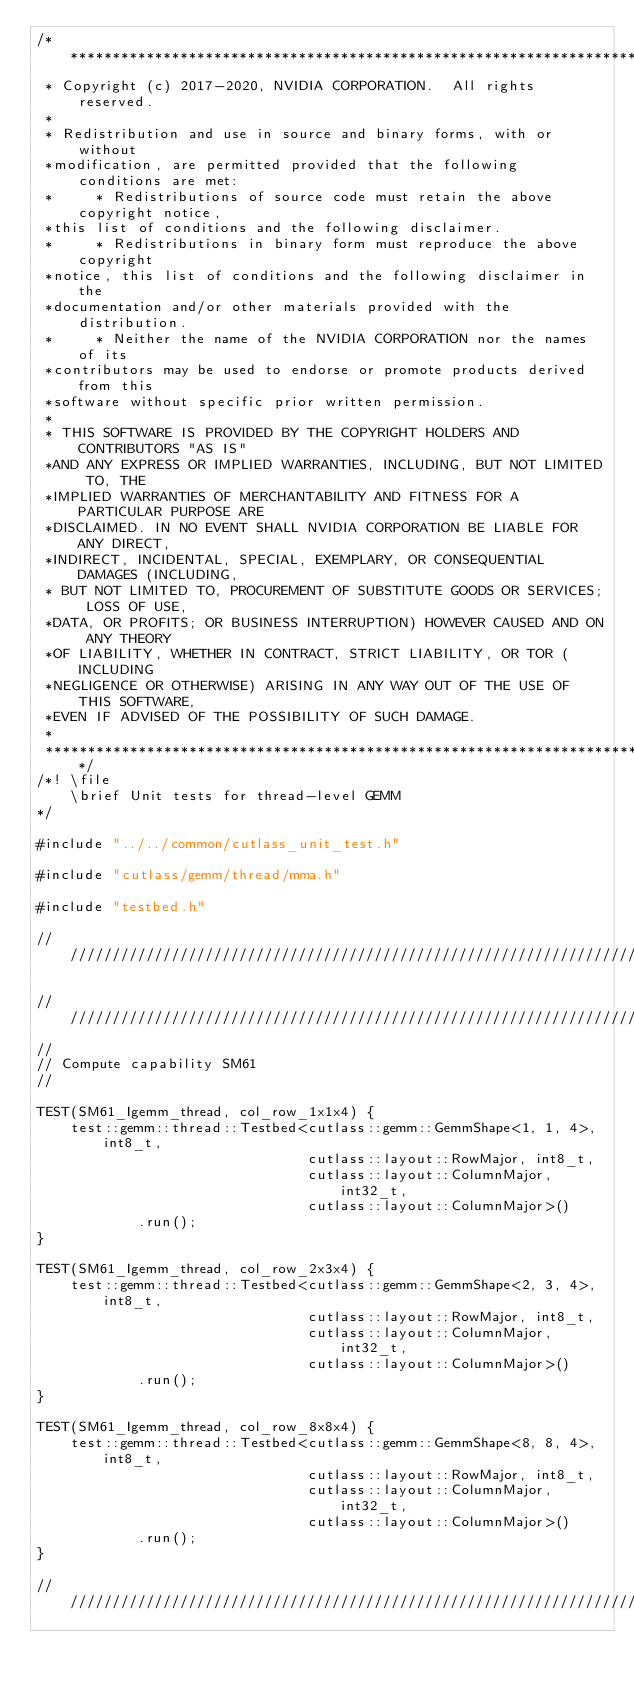<code> <loc_0><loc_0><loc_500><loc_500><_Cuda_>/***************************************************************************************************
 * Copyright (c) 2017-2020, NVIDIA CORPORATION.  All rights reserved.
 *
 * Redistribution and use in source and binary forms, with or without
 *modification, are permitted provided that the following conditions are met:
 *     * Redistributions of source code must retain the above copyright notice,
 *this list of conditions and the following disclaimer.
 *     * Redistributions in binary form must reproduce the above copyright
 *notice, this list of conditions and the following disclaimer in the
 *documentation and/or other materials provided with the distribution.
 *     * Neither the name of the NVIDIA CORPORATION nor the names of its
 *contributors may be used to endorse or promote products derived from this
 *software without specific prior written permission.
 *
 * THIS SOFTWARE IS PROVIDED BY THE COPYRIGHT HOLDERS AND CONTRIBUTORS "AS IS"
 *AND ANY EXPRESS OR IMPLIED WARRANTIES, INCLUDING, BUT NOT LIMITED TO, THE
 *IMPLIED WARRANTIES OF MERCHANTABILITY AND FITNESS FOR A PARTICULAR PURPOSE ARE
 *DISCLAIMED. IN NO EVENT SHALL NVIDIA CORPORATION BE LIABLE FOR ANY DIRECT,
 *INDIRECT, INCIDENTAL, SPECIAL, EXEMPLARY, OR CONSEQUENTIAL DAMAGES (INCLUDING,
 * BUT NOT LIMITED TO, PROCUREMENT OF SUBSTITUTE GOODS OR SERVICES; LOSS OF USE,
 *DATA, OR PROFITS; OR BUSINESS INTERRUPTION) HOWEVER CAUSED AND ON ANY THEORY
 *OF LIABILITY, WHETHER IN CONTRACT, STRICT LIABILITY, OR TOR (INCLUDING
 *NEGLIGENCE OR OTHERWISE) ARISING IN ANY WAY OUT OF THE USE OF THIS SOFTWARE,
 *EVEN IF ADVISED OF THE POSSIBILITY OF SUCH DAMAGE.
 *
 **************************************************************************************************/
/*! \file
    \brief Unit tests for thread-level GEMM
*/

#include "../../common/cutlass_unit_test.h"

#include "cutlass/gemm/thread/mma.h"

#include "testbed.h"

/////////////////////////////////////////////////////////////////////////////////////////////////

/////////////////////////////////////////////////////////////////////////////////////////////////
//
// Compute capability SM61
//

TEST(SM61_Igemm_thread, col_row_1x1x4) {
    test::gemm::thread::Testbed<cutlass::gemm::GemmShape<1, 1, 4>, int8_t,
                                cutlass::layout::RowMajor, int8_t,
                                cutlass::layout::ColumnMajor, int32_t,
                                cutlass::layout::ColumnMajor>()
            .run();
}

TEST(SM61_Igemm_thread, col_row_2x3x4) {
    test::gemm::thread::Testbed<cutlass::gemm::GemmShape<2, 3, 4>, int8_t,
                                cutlass::layout::RowMajor, int8_t,
                                cutlass::layout::ColumnMajor, int32_t,
                                cutlass::layout::ColumnMajor>()
            .run();
}

TEST(SM61_Igemm_thread, col_row_8x8x4) {
    test::gemm::thread::Testbed<cutlass::gemm::GemmShape<8, 8, 4>, int8_t,
                                cutlass::layout::RowMajor, int8_t,
                                cutlass::layout::ColumnMajor, int32_t,
                                cutlass::layout::ColumnMajor>()
            .run();
}

/////////////////////////////////////////////////////////////////////////////////////////////////
</code> 